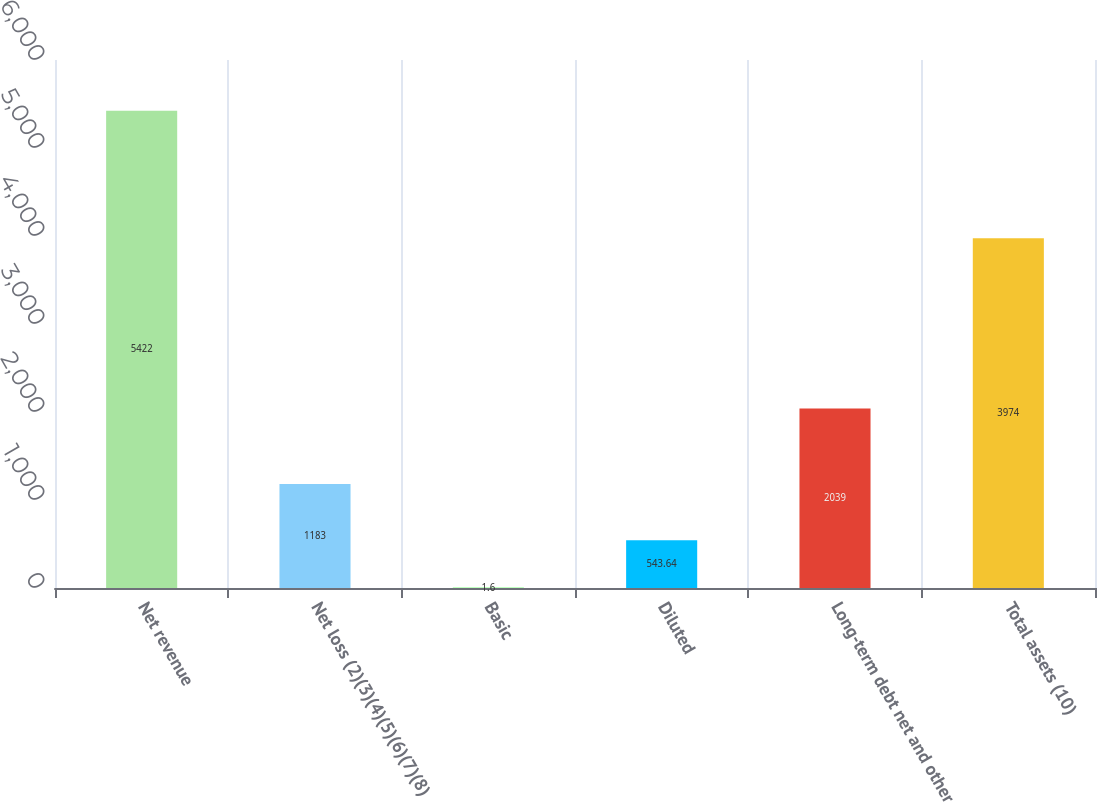Convert chart. <chart><loc_0><loc_0><loc_500><loc_500><bar_chart><fcel>Net revenue<fcel>Net loss (2)(3)(4)(5)(6)(7)(8)<fcel>Basic<fcel>Diluted<fcel>Long-term debt net and other<fcel>Total assets (10)<nl><fcel>5422<fcel>1183<fcel>1.6<fcel>543.64<fcel>2039<fcel>3974<nl></chart> 